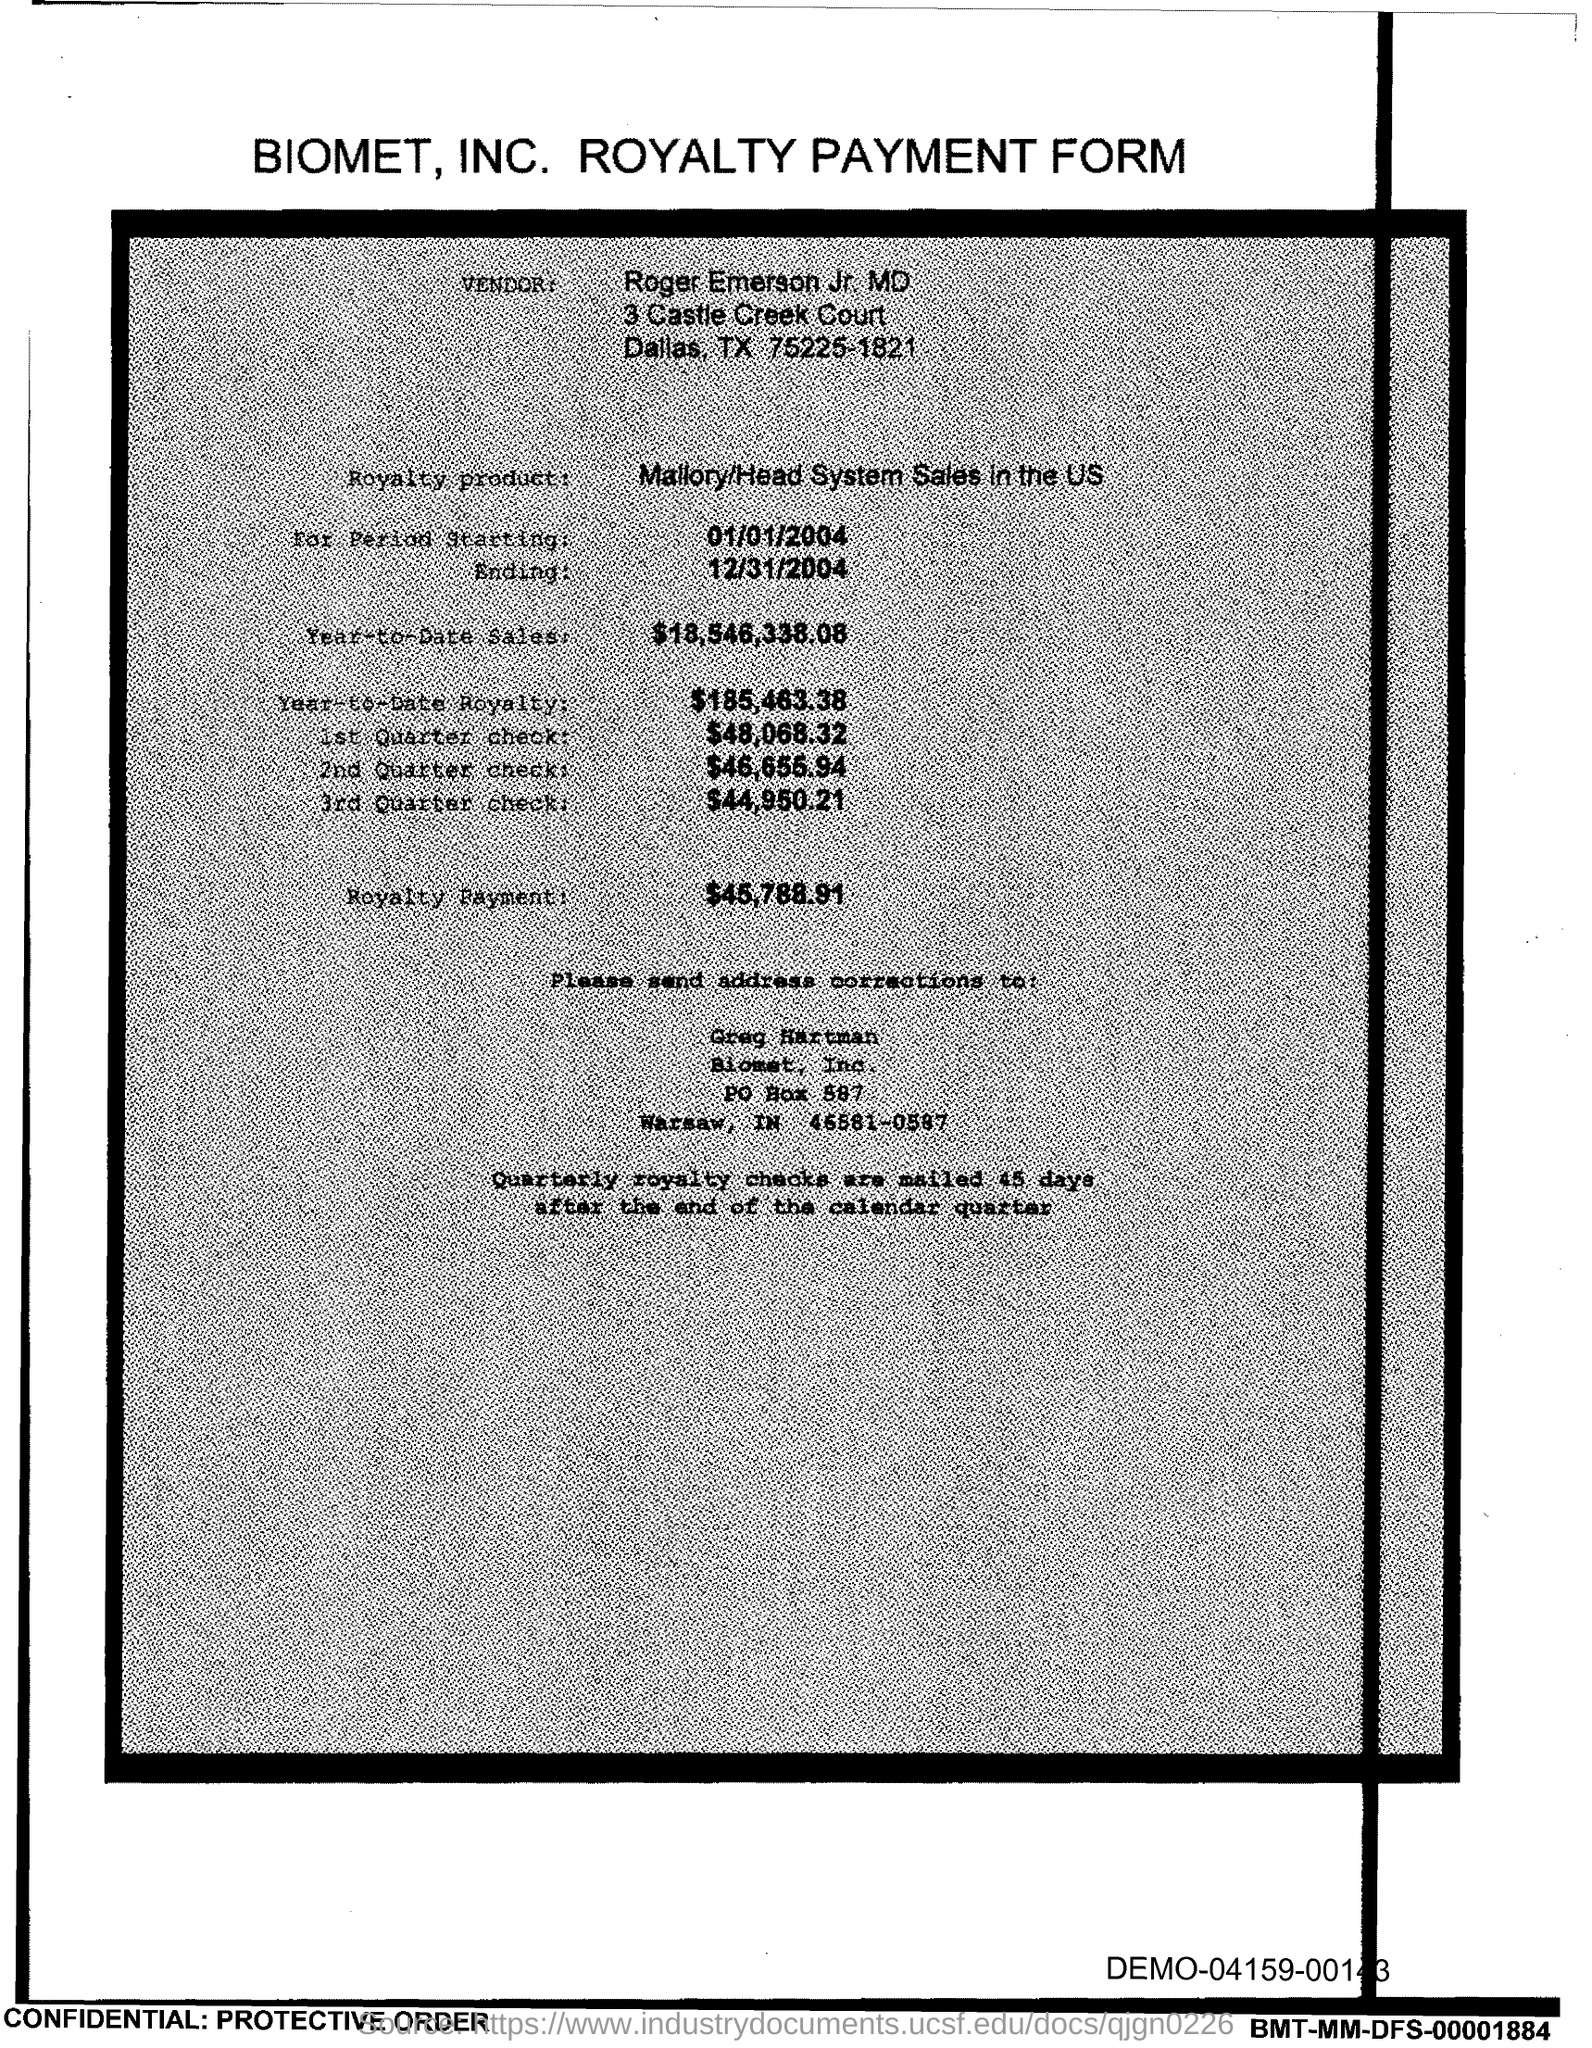Draw attention to some important aspects in this diagram. Roger Emerson Jr. is the vendor. The Royalty product mentioned is the Mallory/Head System Sales in the US. The document is about Biomet, Inc. and its royalty payment form. 